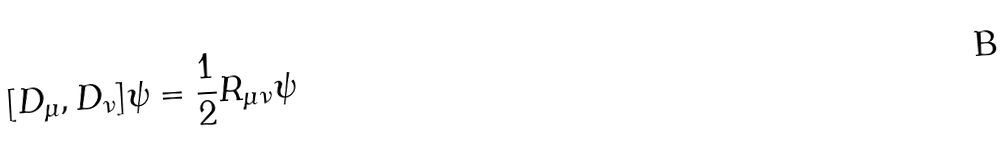<formula> <loc_0><loc_0><loc_500><loc_500>[ D _ { \mu } , D _ { \nu } ] \psi = { \frac { 1 } { 2 } } { R } _ { \mu \nu } \psi</formula> 